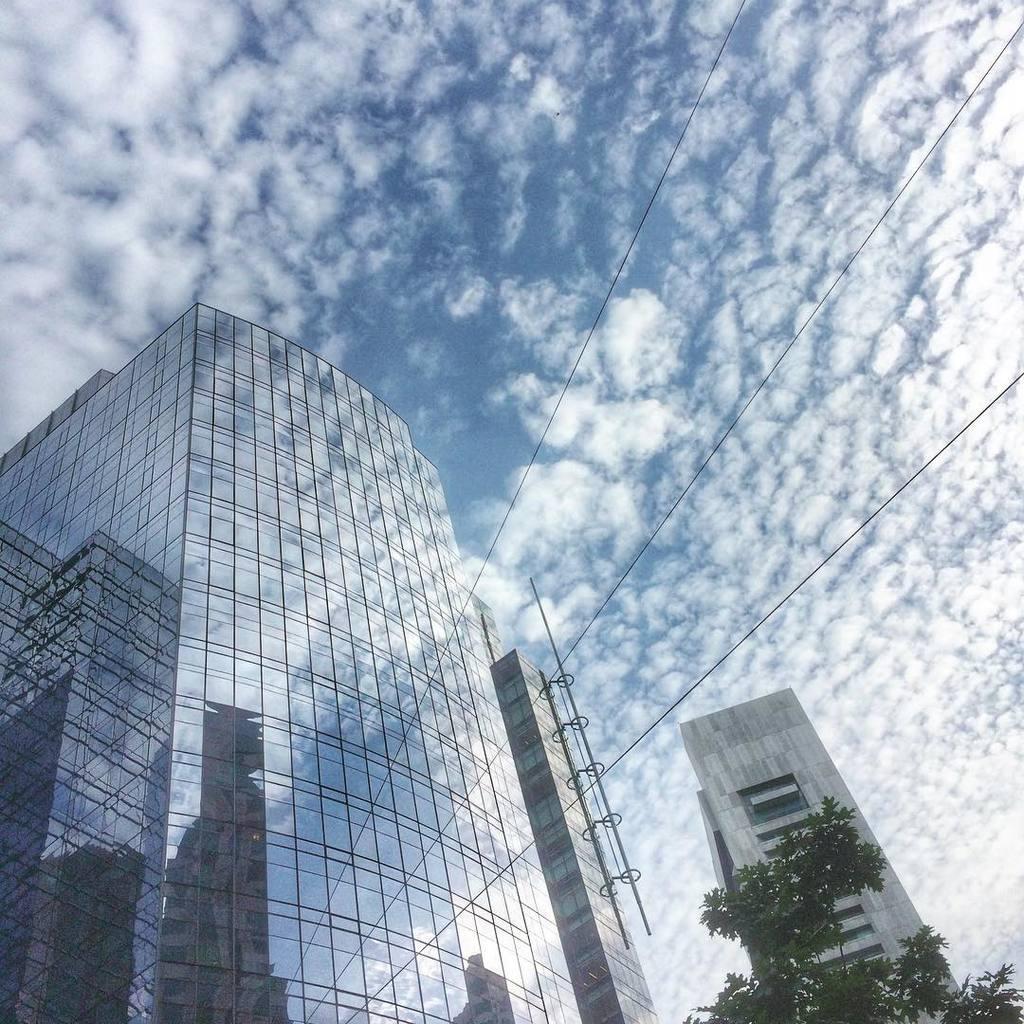Describe this image in one or two sentences. In the picture we can see a tower building with full of glasses to it and beside it, we can see a tree and another tower building and in the background we can see a sky with clouds. 